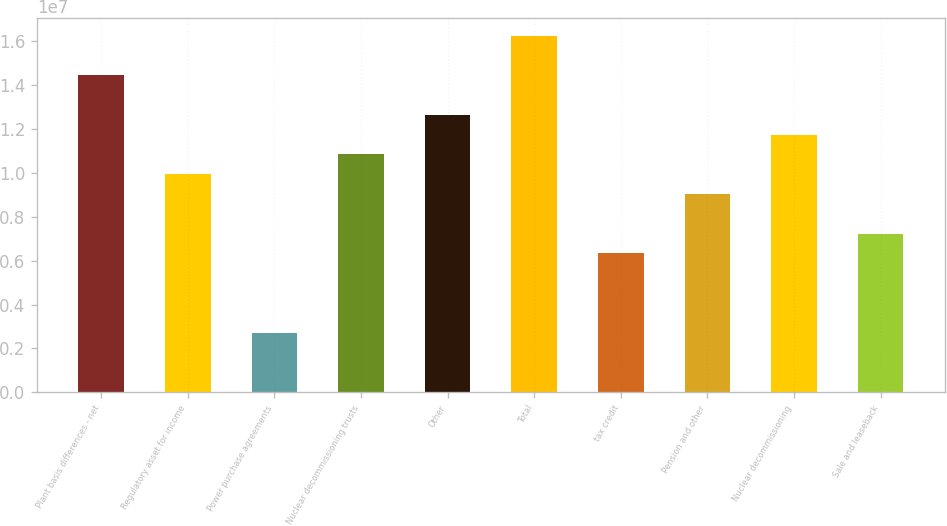Convert chart. <chart><loc_0><loc_0><loc_500><loc_500><bar_chart><fcel>Plant basis differences - net<fcel>Regulatory asset for income<fcel>Power purchase agreements<fcel>Nuclear decommissioning trusts<fcel>Other<fcel>Total<fcel>tax credit<fcel>Pension and other<fcel>Nuclear decommissioning<fcel>Sale and leaseback<nl><fcel>1.44527e+07<fcel>9.94003e+06<fcel>2.7198e+06<fcel>1.08426e+07<fcel>1.26476e+07<fcel>1.62577e+07<fcel>6.32991e+06<fcel>9.0375e+06<fcel>1.17451e+07<fcel>7.23244e+06<nl></chart> 